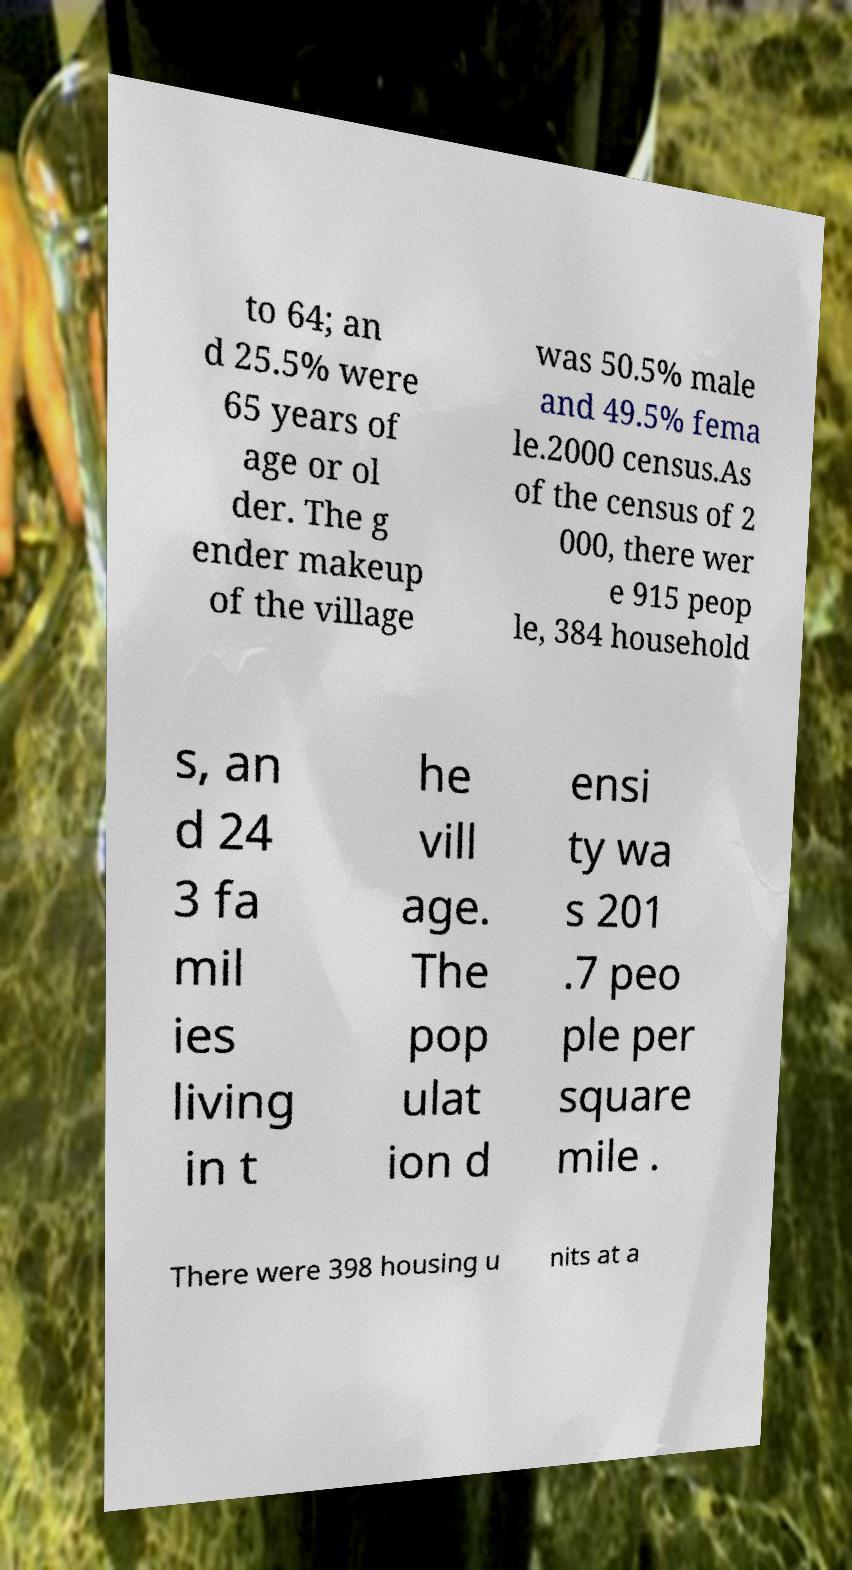Can you accurately transcribe the text from the provided image for me? to 64; an d 25.5% were 65 years of age or ol der. The g ender makeup of the village was 50.5% male and 49.5% fema le.2000 census.As of the census of 2 000, there wer e 915 peop le, 384 household s, an d 24 3 fa mil ies living in t he vill age. The pop ulat ion d ensi ty wa s 201 .7 peo ple per square mile . There were 398 housing u nits at a 